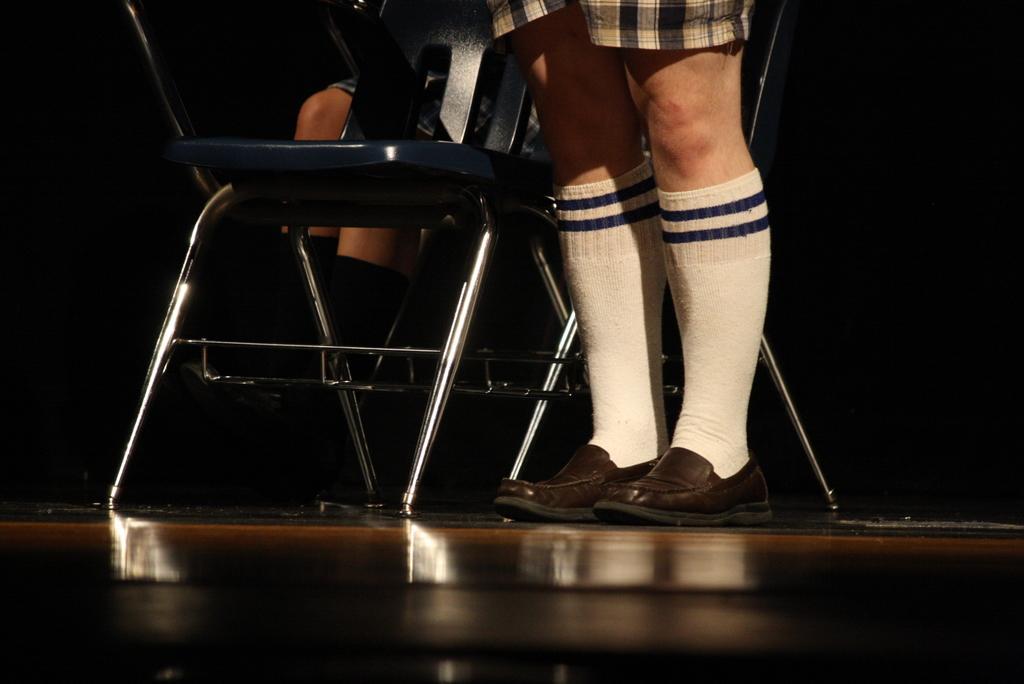In one or two sentences, can you explain what this image depicts? In this image there are legs of a person, beside the legs there is a chair, behind the chair there are legs of another person. 